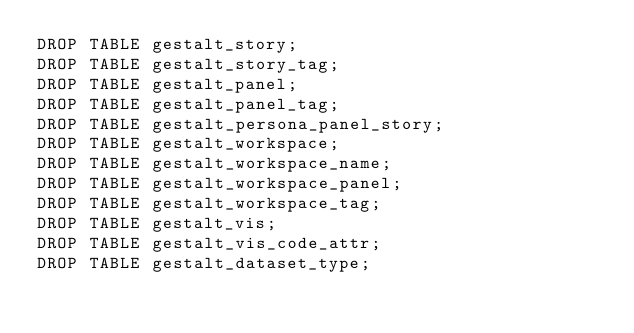Convert code to text. <code><loc_0><loc_0><loc_500><loc_500><_SQL_>DROP TABLE gestalt_story;
DROP TABLE gestalt_story_tag;
DROP TABLE gestalt_panel;
DROP TABLE gestalt_panel_tag;
DROP TABLE gestalt_persona_panel_story;
DROP TABLE gestalt_workspace;
DROP TABLE gestalt_workspace_name;
DROP TABLE gestalt_workspace_panel;
DROP TABLE gestalt_workspace_tag;
DROP TABLE gestalt_vis;
DROP TABLE gestalt_vis_code_attr;
DROP TABLE gestalt_dataset_type;</code> 